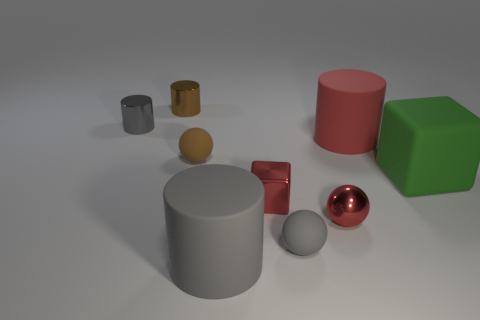Are there fewer red rubber cylinders that are on the left side of the tiny red block than metal objects to the right of the tiny gray metal object?
Give a very brief answer. Yes. There is another small object that is the same shape as the green thing; what color is it?
Provide a short and direct response. Red. Do the large red rubber object and the tiny brown thing that is behind the large red matte cylinder have the same shape?
Offer a terse response. Yes. How many things are either tiny balls on the left side of the small metal ball or objects that are right of the red metal sphere?
Make the answer very short. 4. What is the tiny brown cylinder made of?
Your answer should be very brief. Metal. What number of other objects are the same size as the brown metallic cylinder?
Offer a very short reply. 5. What is the size of the red rubber cylinder right of the small brown metal object?
Your answer should be very brief. Large. What is the material of the gray cylinder on the right side of the metal object behind the small gray object to the left of the brown cylinder?
Give a very brief answer. Rubber. Is the shape of the large gray matte object the same as the large red matte thing?
Give a very brief answer. Yes. How many metallic objects are tiny cylinders or large green cylinders?
Your response must be concise. 2. 